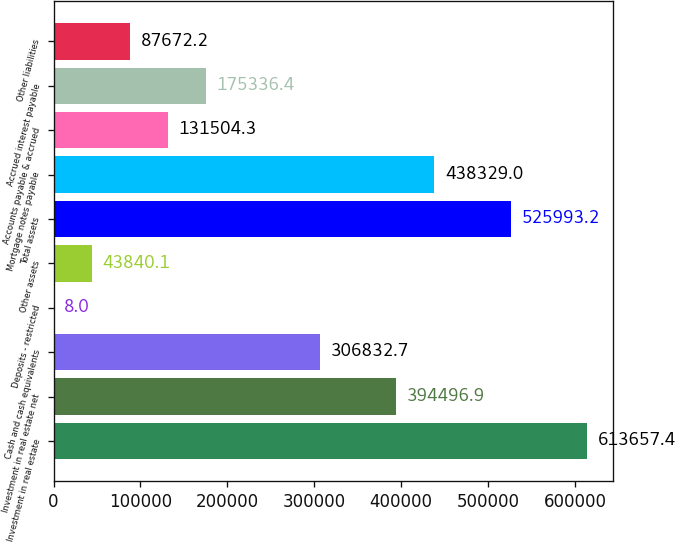<chart> <loc_0><loc_0><loc_500><loc_500><bar_chart><fcel>Investment in real estate<fcel>Investment in real estate net<fcel>Cash and cash equivalents<fcel>Deposits - restricted<fcel>Other assets<fcel>Total assets<fcel>Mortgage notes payable<fcel>Accounts payable & accrued<fcel>Accrued interest payable<fcel>Other liabilities<nl><fcel>613657<fcel>394497<fcel>306833<fcel>8<fcel>43840.1<fcel>525993<fcel>438329<fcel>131504<fcel>175336<fcel>87672.2<nl></chart> 